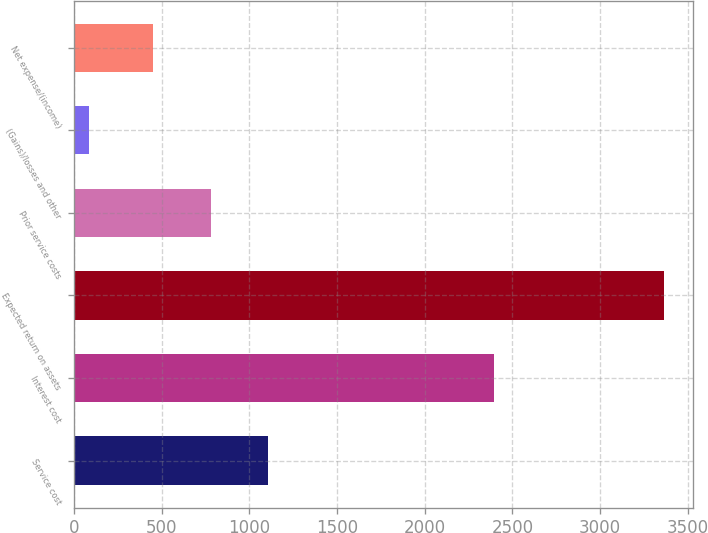Convert chart to OTSL. <chart><loc_0><loc_0><loc_500><loc_500><bar_chart><fcel>Service cost<fcel>Interest cost<fcel>Expected return on assets<fcel>Prior service costs<fcel>(Gains)/losses and other<fcel>Net expense/(income)<nl><fcel>1107<fcel>2398<fcel>3363<fcel>779.5<fcel>88<fcel>452<nl></chart> 